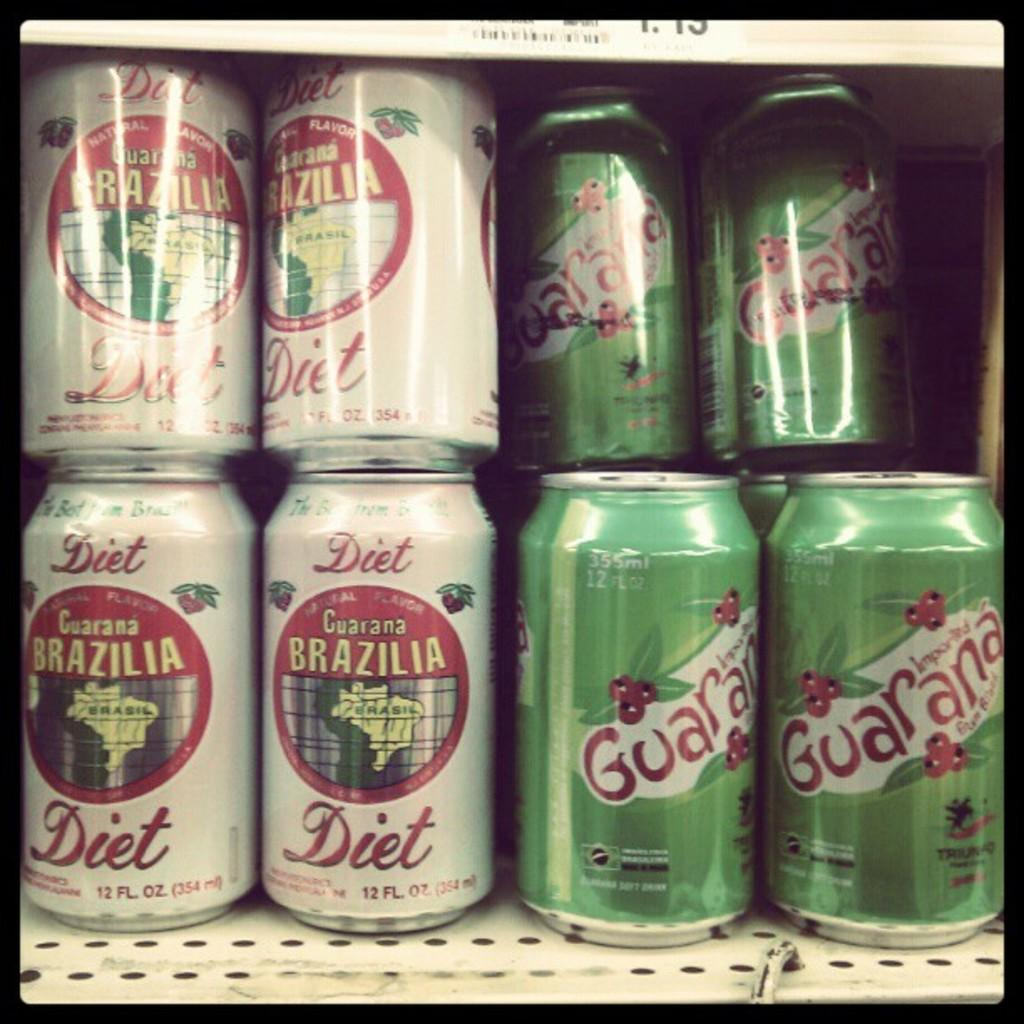<image>
Describe the image concisely. A shelf of Brazilian sodas one diet and the other flavored cherry. 